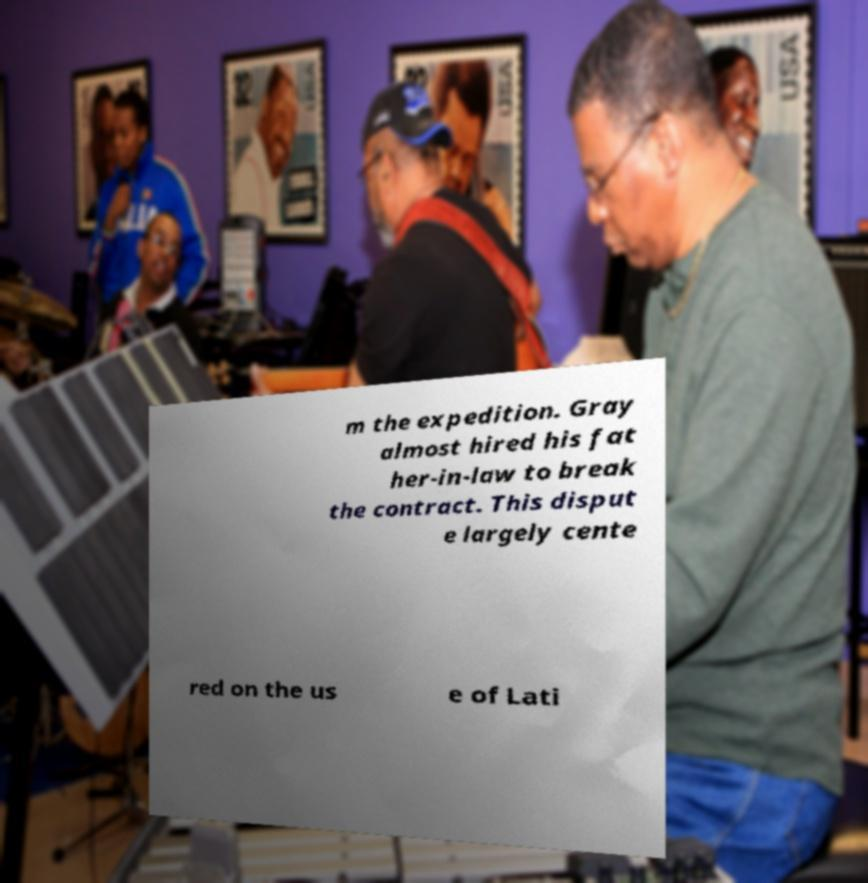Could you assist in decoding the text presented in this image and type it out clearly? m the expedition. Gray almost hired his fat her-in-law to break the contract. This disput e largely cente red on the us e of Lati 